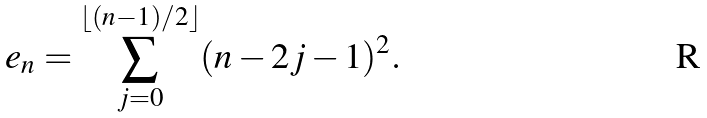Convert formula to latex. <formula><loc_0><loc_0><loc_500><loc_500>e _ { n } = \sum _ { j = 0 } ^ { \lfloor ( n - 1 ) / 2 \rfloor } ( n - 2 j - 1 ) ^ { 2 } .</formula> 